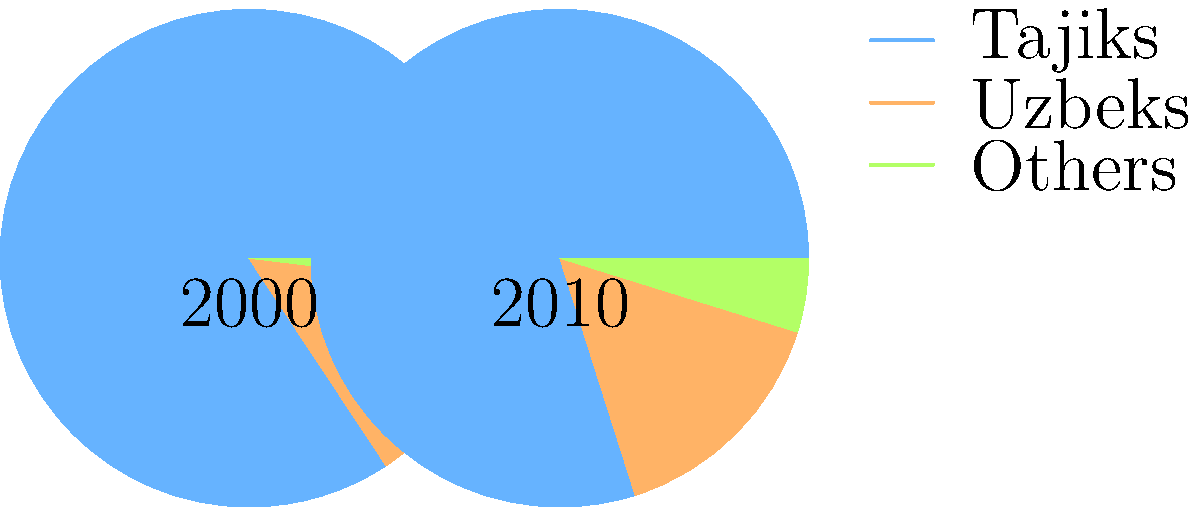Compare the ethnic composition of Tajikistan between 2000 and 2010 as shown in the pie charts. Which ethnic group experienced the most significant percentage increase, and by how much did its share grow? To answer this question, we need to compare the percentages for each ethnic group between 2000 and 2010:

1. Tajiks:
   2000: 84.3%
   2010: 79.9%
   Change: -4.4%

2. Uzbeks:
   2000: 13.8%
   2010: 15.3%
   Change: +1.5%

3. Others:
   2000: 1.9%
   2010: 4.8%
   Change: +2.9%

The "Others" category experienced the most significant percentage increase. To calculate the exact increase:

4.8% - 1.9% = 2.9%

This represents a 2.9 percentage point increase in the share of the "Others" category from 2000 to 2010.
Answer: Others, 2.9 percentage points 